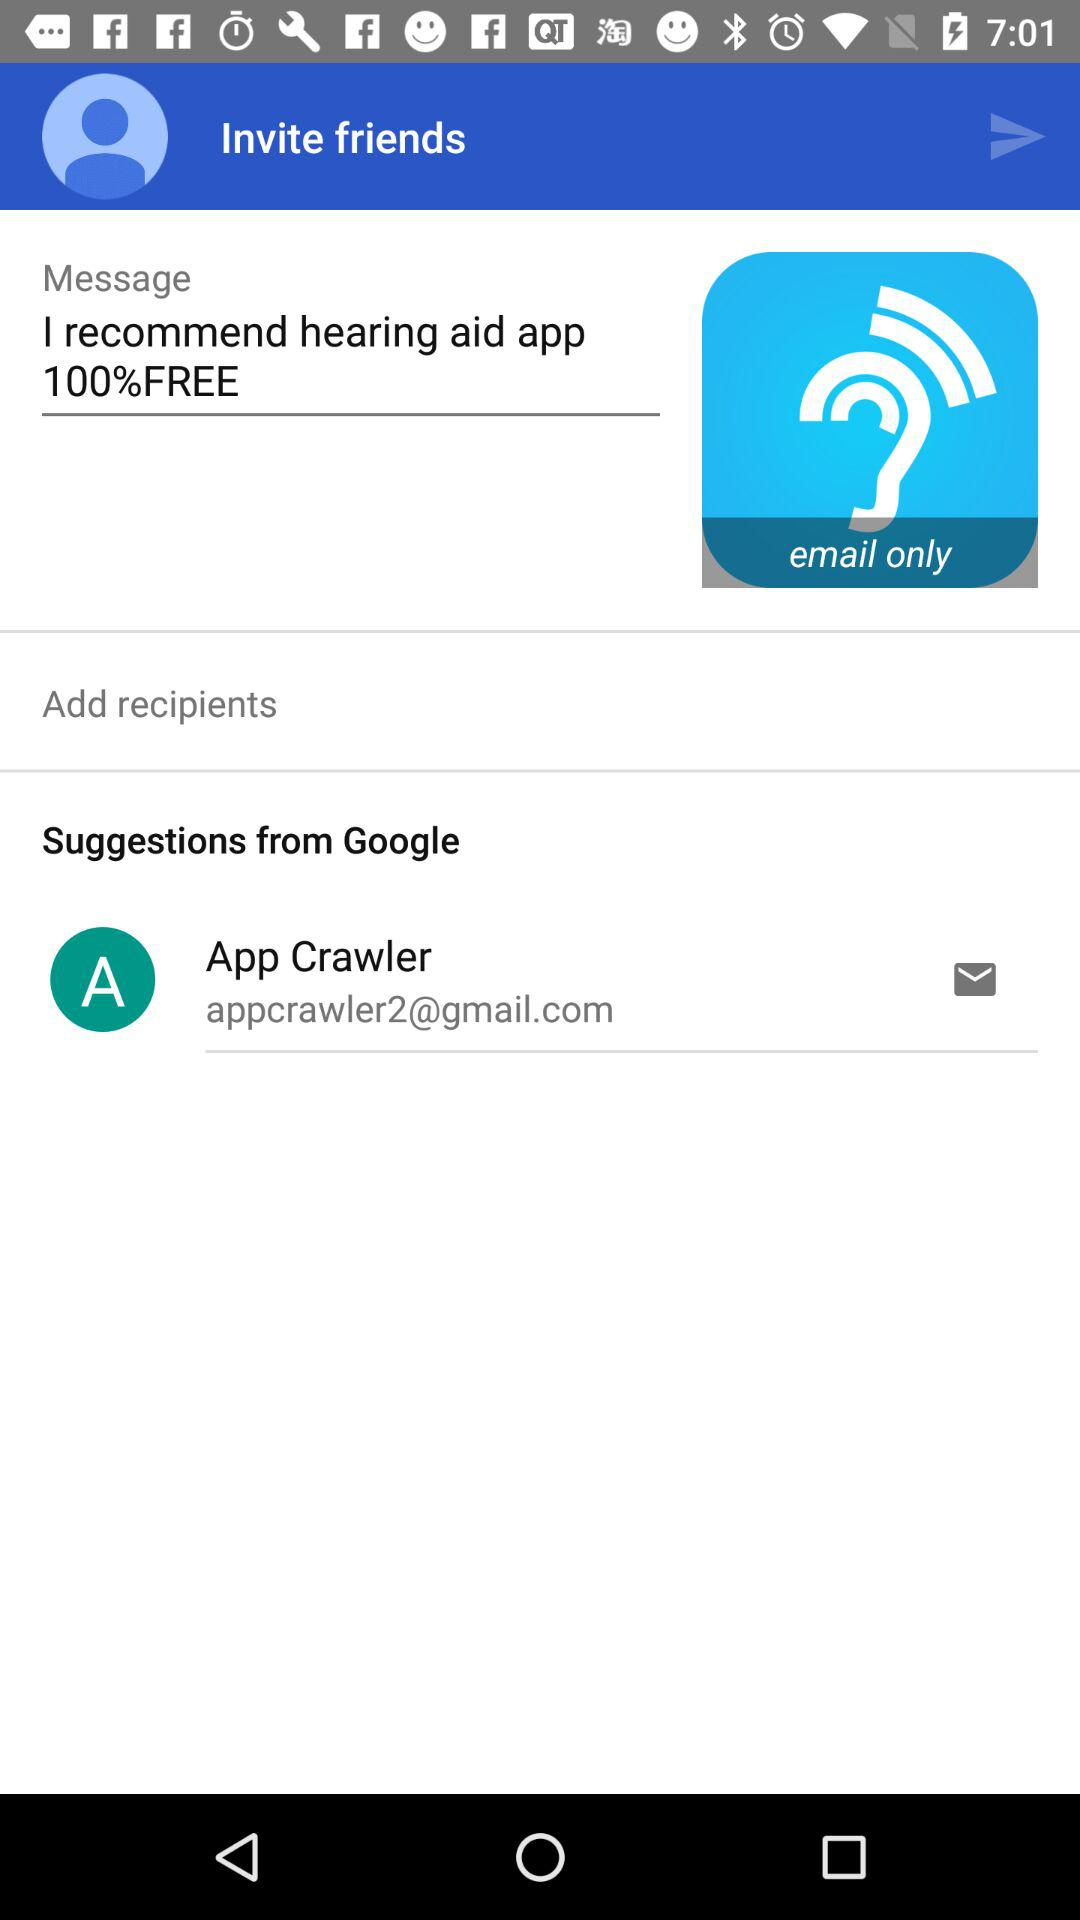What is the user name? The user name is App Crawler. 